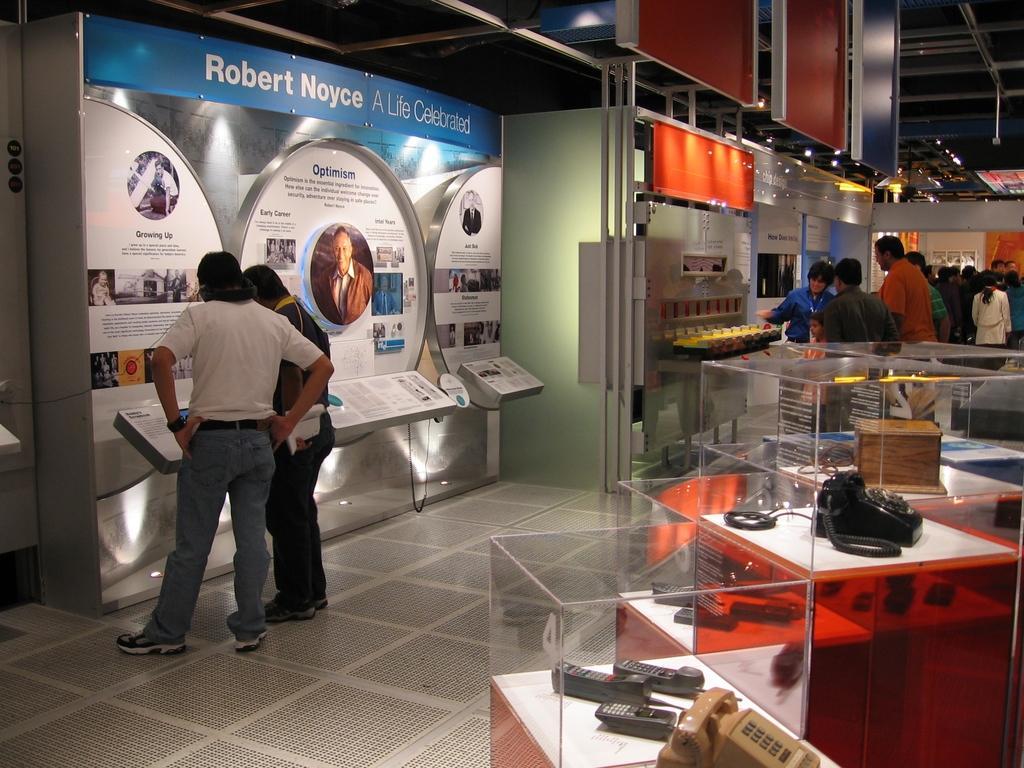Describe this image in one or two sentences. In this picture I can see landline phones and some other objects in the glass boxes, there are group of people standing, there are lights ,boards and some other items. 